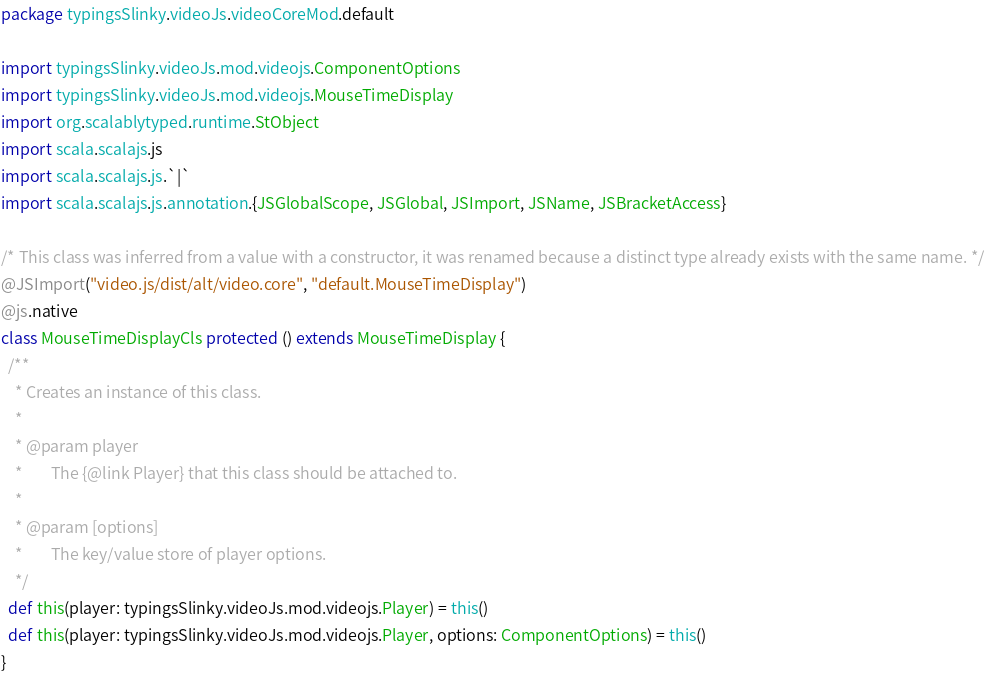Convert code to text. <code><loc_0><loc_0><loc_500><loc_500><_Scala_>package typingsSlinky.videoJs.videoCoreMod.default

import typingsSlinky.videoJs.mod.videojs.ComponentOptions
import typingsSlinky.videoJs.mod.videojs.MouseTimeDisplay
import org.scalablytyped.runtime.StObject
import scala.scalajs.js
import scala.scalajs.js.`|`
import scala.scalajs.js.annotation.{JSGlobalScope, JSGlobal, JSImport, JSName, JSBracketAccess}

/* This class was inferred from a value with a constructor, it was renamed because a distinct type already exists with the same name. */
@JSImport("video.js/dist/alt/video.core", "default.MouseTimeDisplay")
@js.native
class MouseTimeDisplayCls protected () extends MouseTimeDisplay {
  /**
    * Creates an instance of this class.
    *
    * @param player
    *        The {@link Player} that this class should be attached to.
    *
    * @param [options]
    *        The key/value store of player options.
    */
  def this(player: typingsSlinky.videoJs.mod.videojs.Player) = this()
  def this(player: typingsSlinky.videoJs.mod.videojs.Player, options: ComponentOptions) = this()
}
</code> 